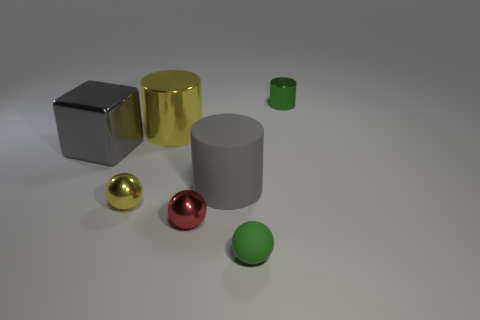Does the big gray metal thing have the same shape as the tiny green thing on the right side of the tiny green sphere?
Provide a succinct answer. No. What is the material of the big gray object that is on the right side of the metallic cylinder that is on the left side of the green thing that is behind the metal block?
Give a very brief answer. Rubber. What number of other things are the same size as the yellow shiny cylinder?
Offer a terse response. 2. Does the rubber sphere have the same color as the large shiny cylinder?
Give a very brief answer. No. There is a small thing behind the big object in front of the big metal block; what number of shiny blocks are behind it?
Provide a short and direct response. 0. There is a gray thing on the left side of the yellow metal object in front of the big block; what is it made of?
Give a very brief answer. Metal. Is there another thing of the same shape as the green matte object?
Offer a very short reply. Yes. What color is the other cylinder that is the same size as the yellow cylinder?
Keep it short and to the point. Gray. What number of objects are objects in front of the large yellow thing or yellow things on the left side of the big yellow metallic thing?
Give a very brief answer. 5. How many objects are either spheres or small purple metallic cubes?
Offer a very short reply. 3. 